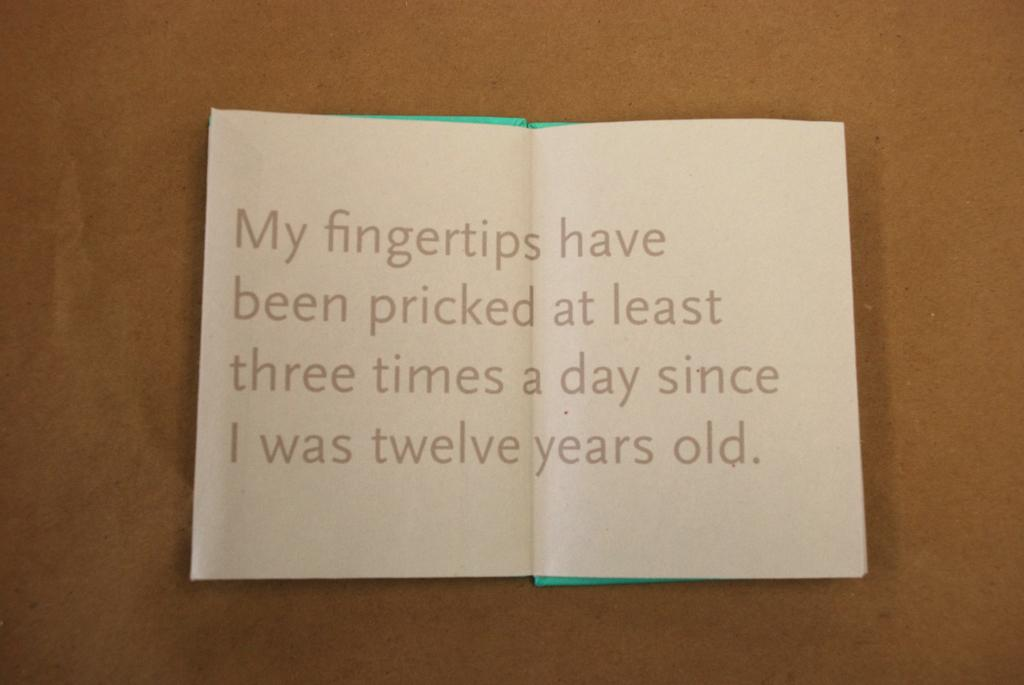Provide a one-sentence caption for the provided image. A sheet of paper stating that my fingertips have been pricked every day since they were twelve years old. 